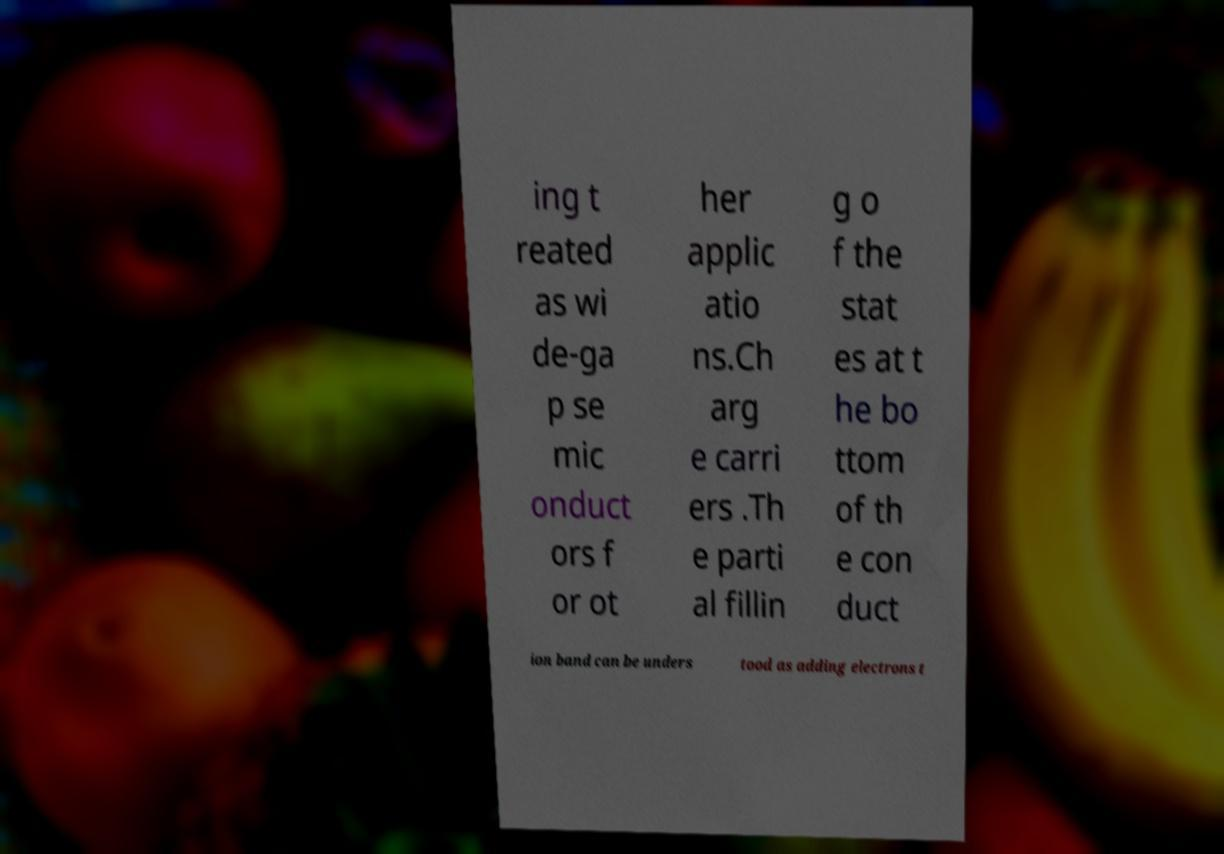There's text embedded in this image that I need extracted. Can you transcribe it verbatim? ing t reated as wi de-ga p se mic onduct ors f or ot her applic atio ns.Ch arg e carri ers .Th e parti al fillin g o f the stat es at t he bo ttom of th e con duct ion band can be unders tood as adding electrons t 